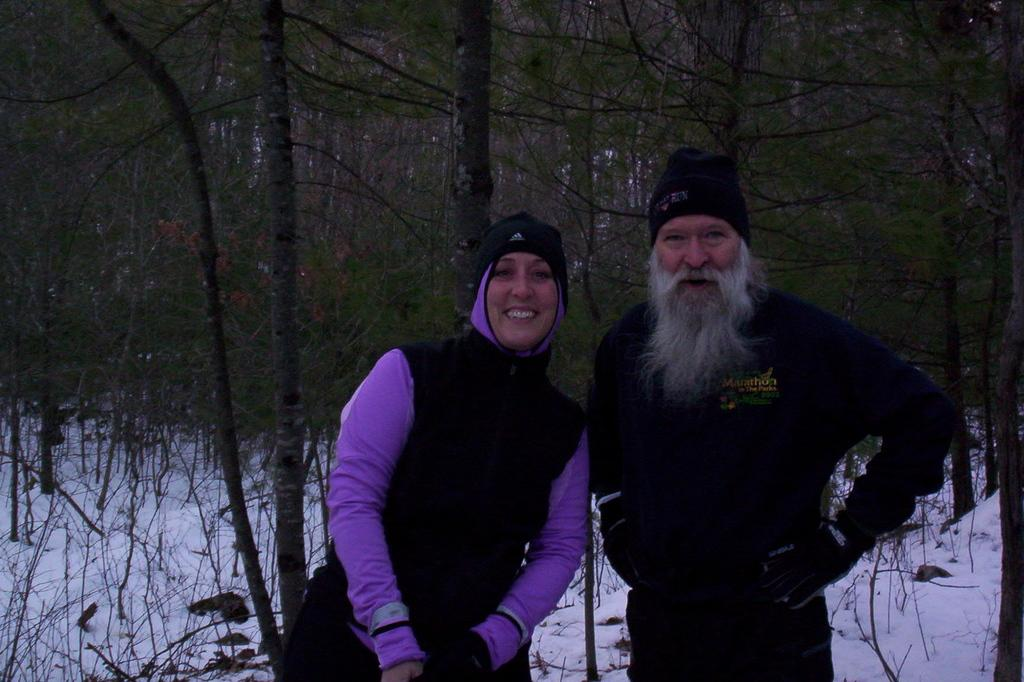How many people are in the image? There are two people in the image. What are the people doing in the image? The people are standing. What are the people wearing in the image? The people are wearing sweaters. What can be seen in the background of the image? There are trees and snow in the background of the image. What type of soda can be seen in the hands of one of the people in the image? There is no soda present in the image; the people are wearing sweaters and standing in a snowy background. 